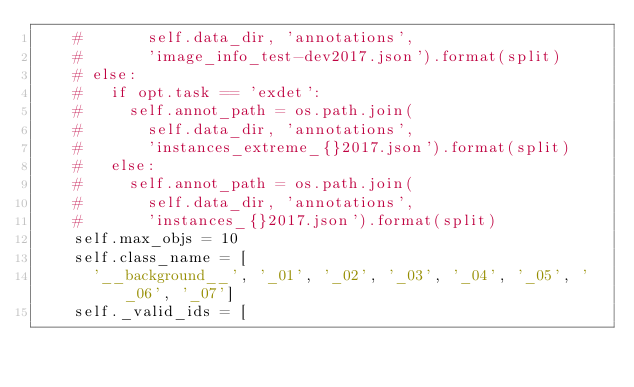Convert code to text. <code><loc_0><loc_0><loc_500><loc_500><_Python_>    #       self.data_dir, 'annotations',
    #       'image_info_test-dev2017.json').format(split)
    # else:
    #   if opt.task == 'exdet':
    #     self.annot_path = os.path.join(
    #       self.data_dir, 'annotations',
    #       'instances_extreme_{}2017.json').format(split)
    #   else:
    #     self.annot_path = os.path.join(
    #       self.data_dir, 'annotations',
    #       'instances_{}2017.json').format(split)
    self.max_objs = 10
    self.class_name = [
      '__background__', '_01', '_02', '_03', '_04', '_05', '_06', '_07']
    self._valid_ids = [</code> 